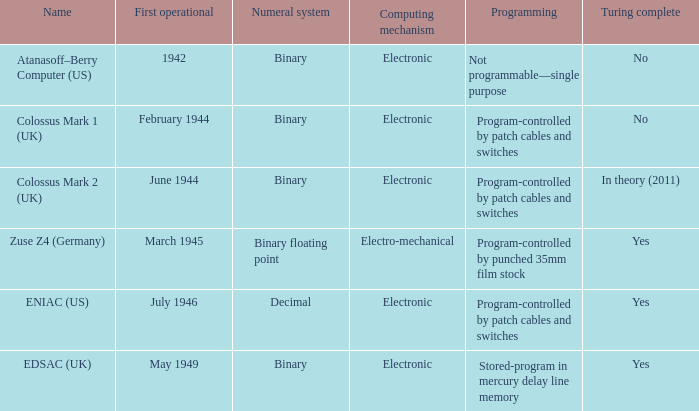What's the name with first operational being march 1945 Zuse Z4 (Germany). 